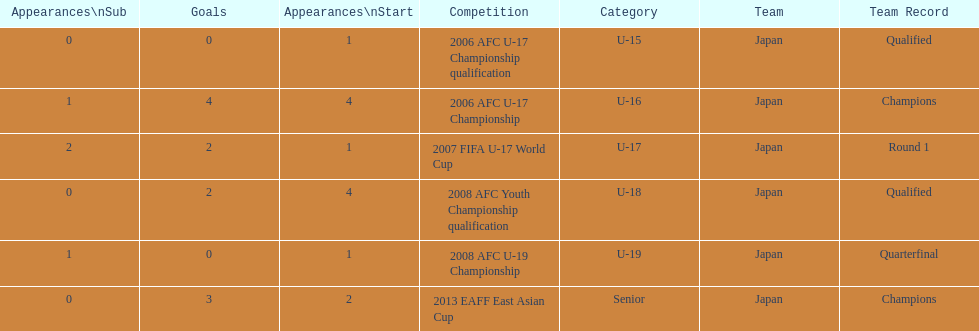Name the earliest competition to have a sub. 2006 AFC U-17 Championship. 